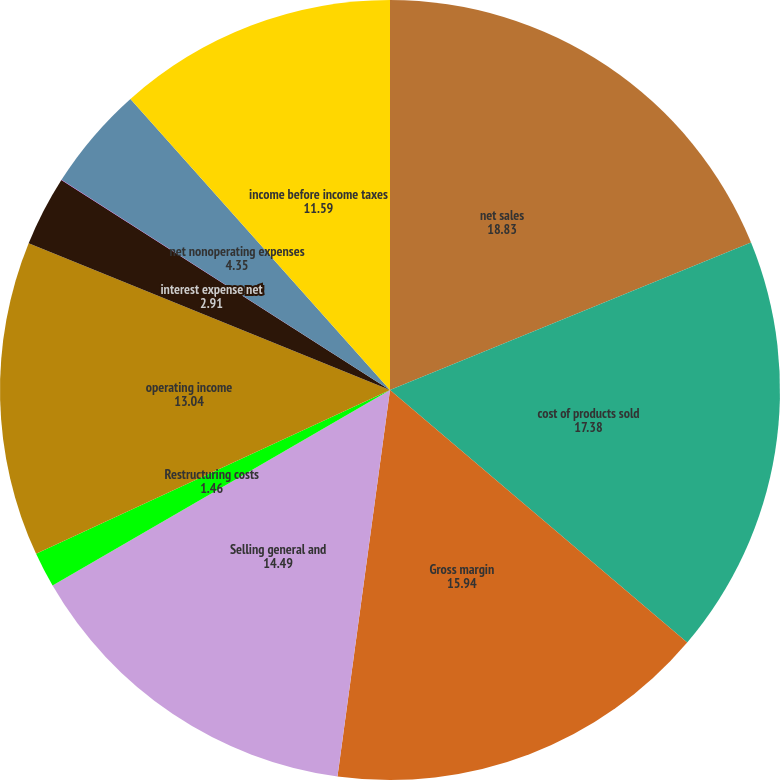<chart> <loc_0><loc_0><loc_500><loc_500><pie_chart><fcel>net sales<fcel>cost of products sold<fcel>Gross margin<fcel>Selling general and<fcel>Restructuring costs<fcel>operating income<fcel>interest expense net<fcel>other expense net<fcel>net nonoperating expenses<fcel>income before income taxes<nl><fcel>18.83%<fcel>17.38%<fcel>15.94%<fcel>14.49%<fcel>1.46%<fcel>13.04%<fcel>2.91%<fcel>0.01%<fcel>4.35%<fcel>11.59%<nl></chart> 